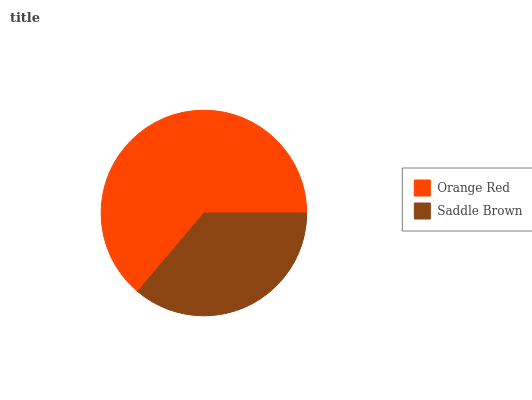Is Saddle Brown the minimum?
Answer yes or no. Yes. Is Orange Red the maximum?
Answer yes or no. Yes. Is Saddle Brown the maximum?
Answer yes or no. No. Is Orange Red greater than Saddle Brown?
Answer yes or no. Yes. Is Saddle Brown less than Orange Red?
Answer yes or no. Yes. Is Saddle Brown greater than Orange Red?
Answer yes or no. No. Is Orange Red less than Saddle Brown?
Answer yes or no. No. Is Orange Red the high median?
Answer yes or no. Yes. Is Saddle Brown the low median?
Answer yes or no. Yes. Is Saddle Brown the high median?
Answer yes or no. No. Is Orange Red the low median?
Answer yes or no. No. 